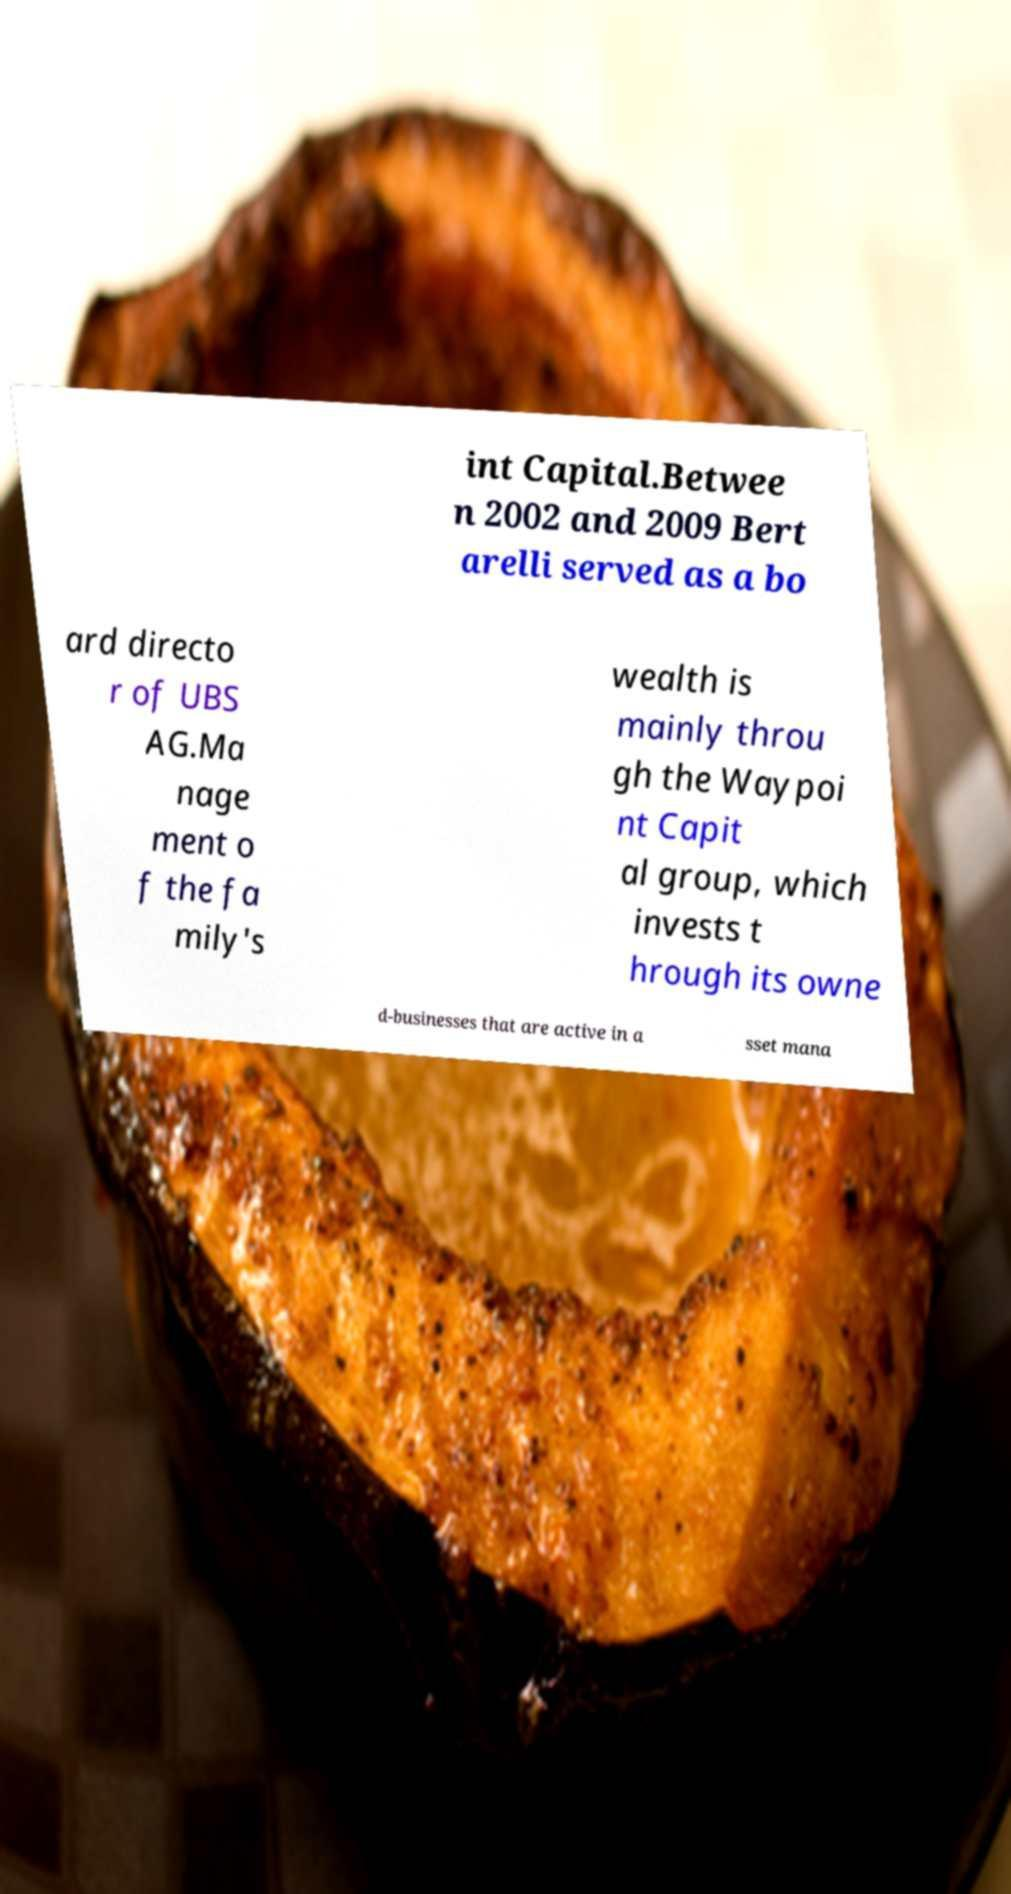Could you assist in decoding the text presented in this image and type it out clearly? int Capital.Betwee n 2002 and 2009 Bert arelli served as a bo ard directo r of UBS AG.Ma nage ment o f the fa mily's wealth is mainly throu gh the Waypoi nt Capit al group, which invests t hrough its owne d-businesses that are active in a sset mana 